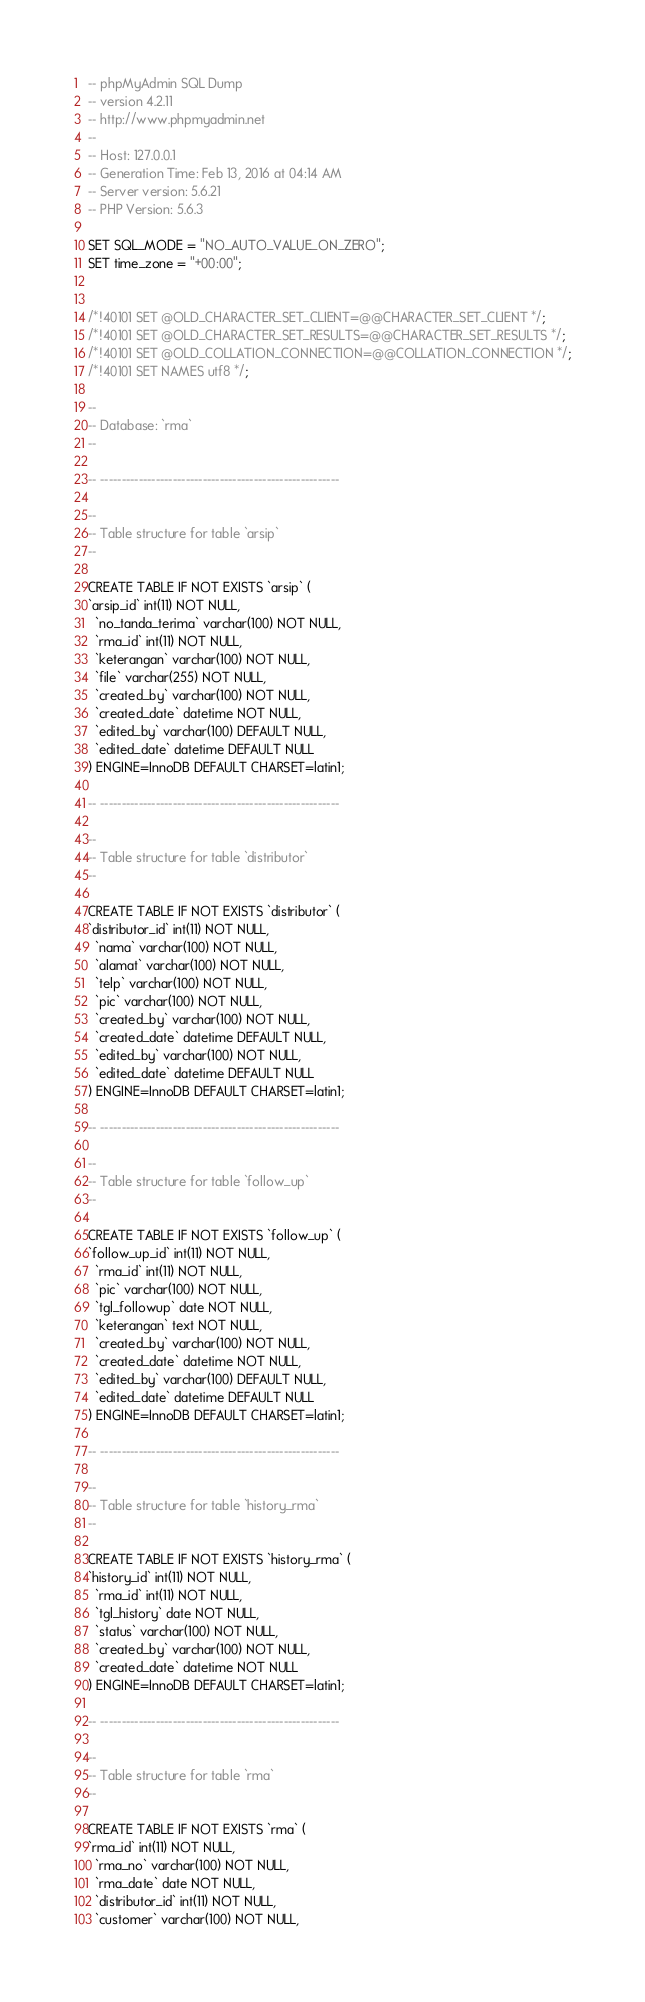Convert code to text. <code><loc_0><loc_0><loc_500><loc_500><_SQL_>-- phpMyAdmin SQL Dump
-- version 4.2.11
-- http://www.phpmyadmin.net
--
-- Host: 127.0.0.1
-- Generation Time: Feb 13, 2016 at 04:14 AM
-- Server version: 5.6.21
-- PHP Version: 5.6.3

SET SQL_MODE = "NO_AUTO_VALUE_ON_ZERO";
SET time_zone = "+00:00";


/*!40101 SET @OLD_CHARACTER_SET_CLIENT=@@CHARACTER_SET_CLIENT */;
/*!40101 SET @OLD_CHARACTER_SET_RESULTS=@@CHARACTER_SET_RESULTS */;
/*!40101 SET @OLD_COLLATION_CONNECTION=@@COLLATION_CONNECTION */;
/*!40101 SET NAMES utf8 */;

--
-- Database: `rma`
--

-- --------------------------------------------------------

--
-- Table structure for table `arsip`
--

CREATE TABLE IF NOT EXISTS `arsip` (
`arsip_id` int(11) NOT NULL,
  `no_tanda_terima` varchar(100) NOT NULL,
  `rma_id` int(11) NOT NULL,
  `keterangan` varchar(100) NOT NULL,
  `file` varchar(255) NOT NULL,
  `created_by` varchar(100) NOT NULL,
  `created_date` datetime NOT NULL,
  `edited_by` varchar(100) DEFAULT NULL,
  `edited_date` datetime DEFAULT NULL
) ENGINE=InnoDB DEFAULT CHARSET=latin1;

-- --------------------------------------------------------

--
-- Table structure for table `distributor`
--

CREATE TABLE IF NOT EXISTS `distributor` (
`distributor_id` int(11) NOT NULL,
  `nama` varchar(100) NOT NULL,
  `alamat` varchar(100) NOT NULL,
  `telp` varchar(100) NOT NULL,
  `pic` varchar(100) NOT NULL,
  `created_by` varchar(100) NOT NULL,
  `created_date` datetime DEFAULT NULL,
  `edited_by` varchar(100) NOT NULL,
  `edited_date` datetime DEFAULT NULL
) ENGINE=InnoDB DEFAULT CHARSET=latin1;

-- --------------------------------------------------------

--
-- Table structure for table `follow_up`
--

CREATE TABLE IF NOT EXISTS `follow_up` (
`follow_up_id` int(11) NOT NULL,
  `rma_id` int(11) NOT NULL,
  `pic` varchar(100) NOT NULL,
  `tgl_followup` date NOT NULL,
  `keterangan` text NOT NULL,
  `created_by` varchar(100) NOT NULL,
  `created_date` datetime NOT NULL,
  `edited_by` varchar(100) DEFAULT NULL,
  `edited_date` datetime DEFAULT NULL
) ENGINE=InnoDB DEFAULT CHARSET=latin1;

-- --------------------------------------------------------

--
-- Table structure for table `history_rma`
--

CREATE TABLE IF NOT EXISTS `history_rma` (
`history_id` int(11) NOT NULL,
  `rma_id` int(11) NOT NULL,
  `tgl_history` date NOT NULL,
  `status` varchar(100) NOT NULL,
  `created_by` varchar(100) NOT NULL,
  `created_date` datetime NOT NULL
) ENGINE=InnoDB DEFAULT CHARSET=latin1;

-- --------------------------------------------------------

--
-- Table structure for table `rma`
--

CREATE TABLE IF NOT EXISTS `rma` (
`rma_id` int(11) NOT NULL,
  `rma_no` varchar(100) NOT NULL,
  `rma_date` date NOT NULL,
  `distributor_id` int(11) NOT NULL,
  `customer` varchar(100) NOT NULL,</code> 